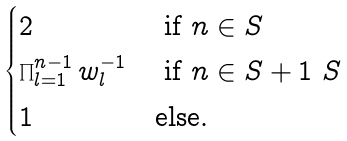<formula> <loc_0><loc_0><loc_500><loc_500>\begin{cases} 2 & \text { if } n \in S \\ \prod _ { l = 1 } ^ { n - 1 } w _ { l } ^ { - 1 } & \text { if } n \in S + 1 \ S \\ 1 & \text {else} . \end{cases}</formula> 